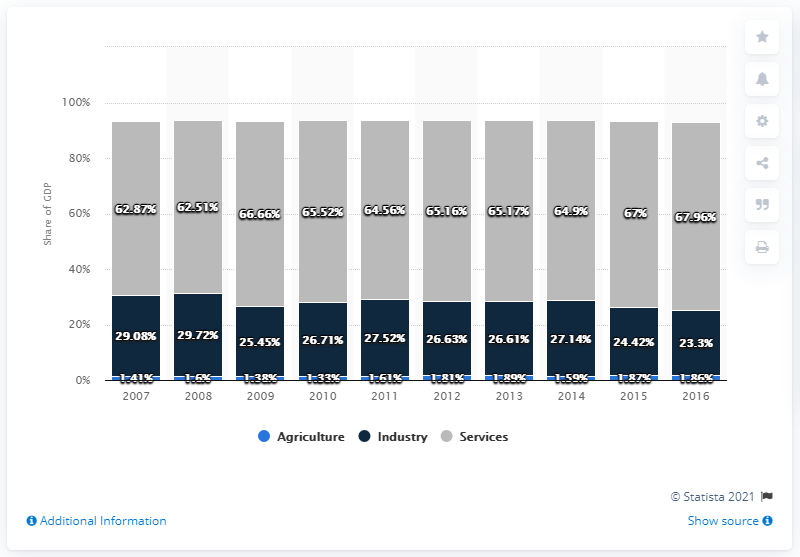Point out several critical features in this image. The industry figure for 2007 was 5.78, while the figure for 2016 was significantly higher at 5.78. Yes, the GDP has exceeded 80% in at least one year. 